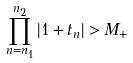<formula> <loc_0><loc_0><loc_500><loc_500>\prod _ { n = n _ { 1 } } ^ { n _ { 2 } } | 1 + t _ { n } | > M _ { + }</formula> 